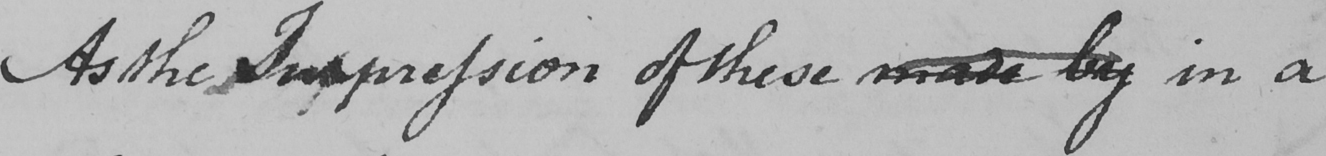What does this handwritten line say? As the Impression of these made by in a 